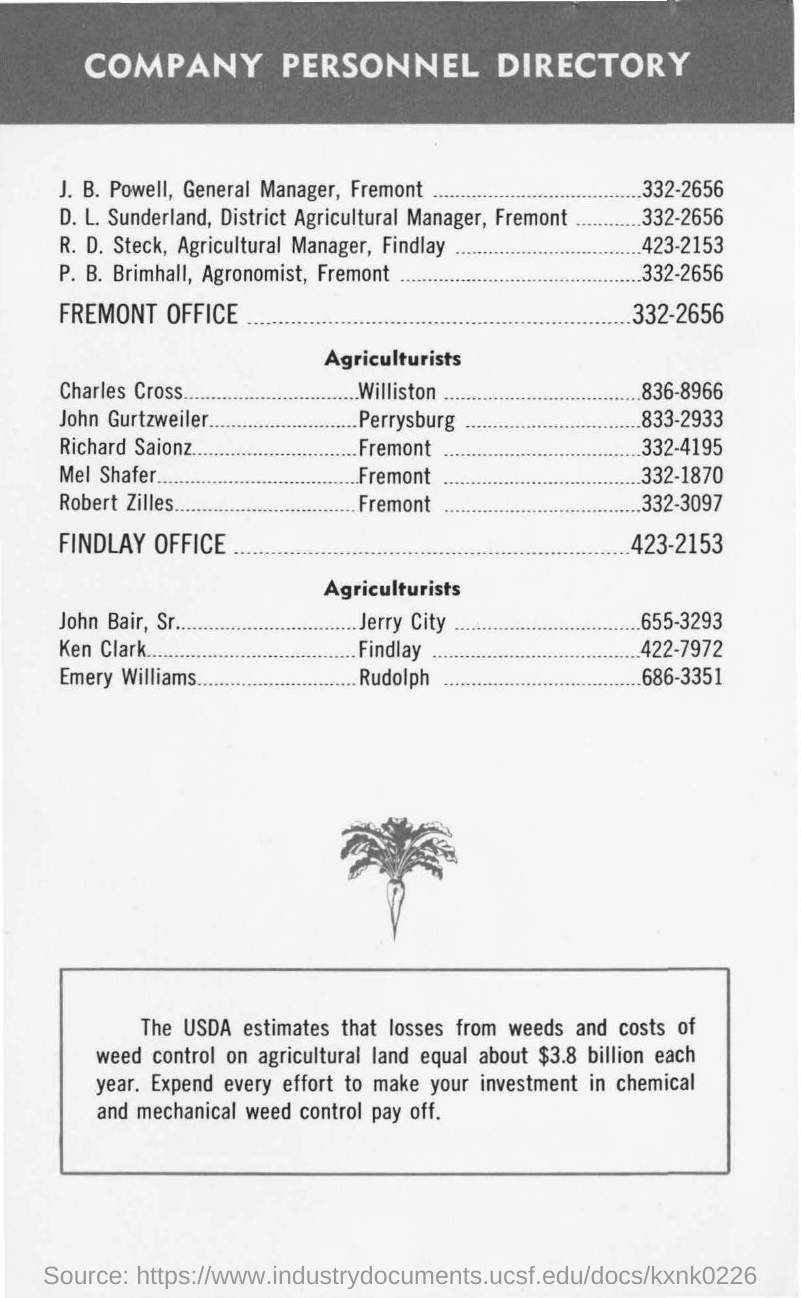Give some essential details in this illustration. The document contains a company personnel directory, which is located at the top of the document. 